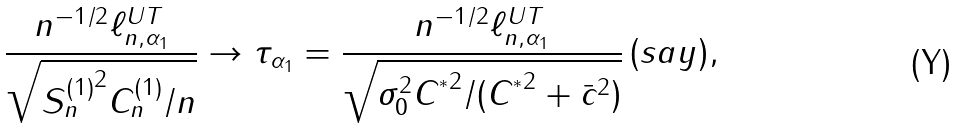<formula> <loc_0><loc_0><loc_500><loc_500>\frac { n ^ { - 1 / 2 } \ell _ { n , \alpha _ { 1 } } ^ { U T } } { \sqrt { { S _ { n } ^ { ( 1 ) } } ^ { 2 } C _ { n } ^ { ( 1 ) } / n } } \rightarrow \tau _ { \alpha _ { 1 } } = \frac { n ^ { - 1 / 2 } \ell _ { n , \alpha _ { 1 } } ^ { U T } } { \sqrt { \sigma _ { 0 } ^ { 2 } { C ^ { ^ { * } } } ^ { 2 } / ( { C ^ { ^ { * } } } ^ { 2 } + \bar { c } ^ { 2 } ) } } \, ( s a y ) ,</formula> 